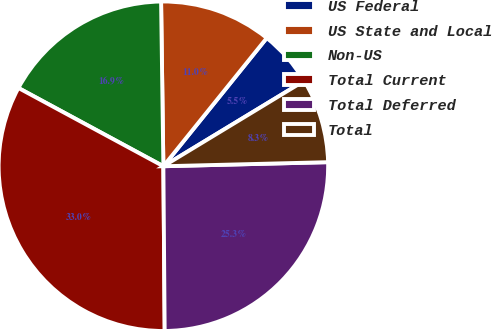<chart> <loc_0><loc_0><loc_500><loc_500><pie_chart><fcel>US Federal<fcel>US State and Local<fcel>Non-US<fcel>Total Current<fcel>Total Deferred<fcel>Total<nl><fcel>5.53%<fcel>11.02%<fcel>16.9%<fcel>33.01%<fcel>25.27%<fcel>8.28%<nl></chart> 